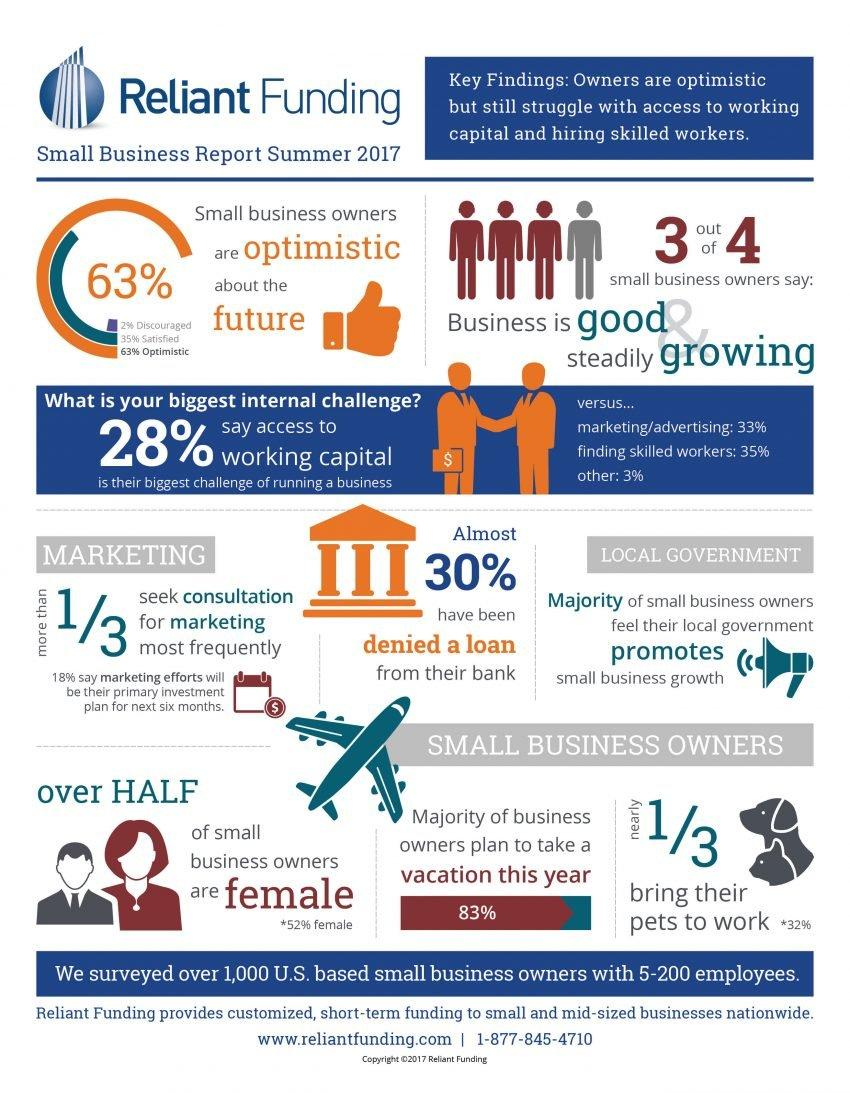List a handful of essential elements in this visual. According to the small business report released in summer 2017, 83% of business owners plan to take a vacation this year. According to the Small Business Report Summer 2017, 52% of small business owners are female. According to the Small Business Report for summer 2017, 35% of small business owners indicated that finding skilled workers was their primary challenge in running their business. According to the Small Business Report Summer 2017, only 2% of small business owners were discouraged about the future. Per the summer 2017 small business report, marketing and advertising were identified as the biggest challenges faced by 33% of small business owners in running their businesses. 